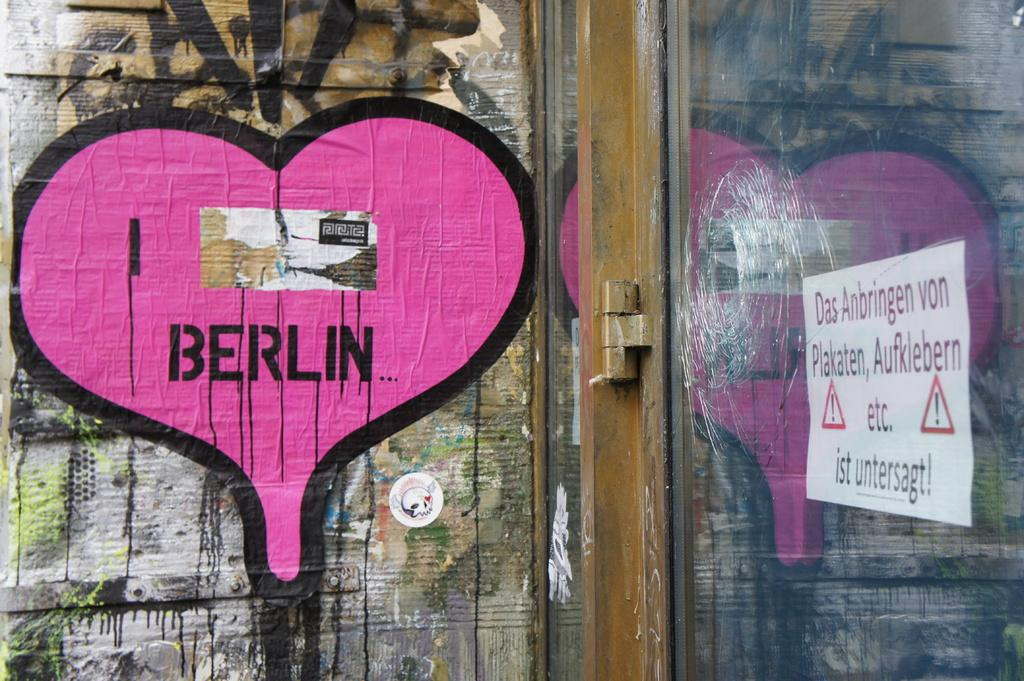What type of artwork is visible in the image? There is a wall painting in the image. What other elements can be seen in the image besides the wall painting? There is a glass element, a board, and a door in the image. Can you describe the lighting conditions in the image? The image was likely taken during the day, as there is sufficient natural light. What type of hair can be seen on the wall painting in the image? There is no hair visible on the wall painting in the image. What event is being celebrated in the image? There is no indication of a specific event being celebrated in the image. 